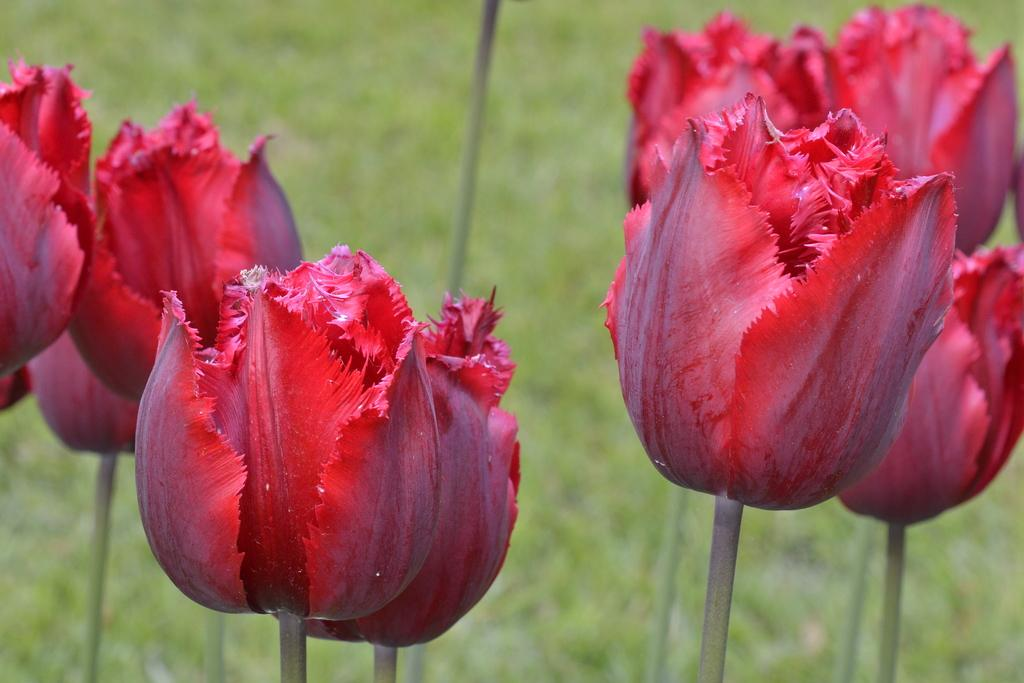What type of flowers can be seen in the image? There are red color flowers in the image. Can you describe the background of the image? The background of the image is blurred. What type of steel is used to make the hat in the image? There is no hat present in the image, so it is not possible to determine what type of steel might be used. What holiday is being celebrated in the image? There is no indication of a holiday being celebrated in the image. 